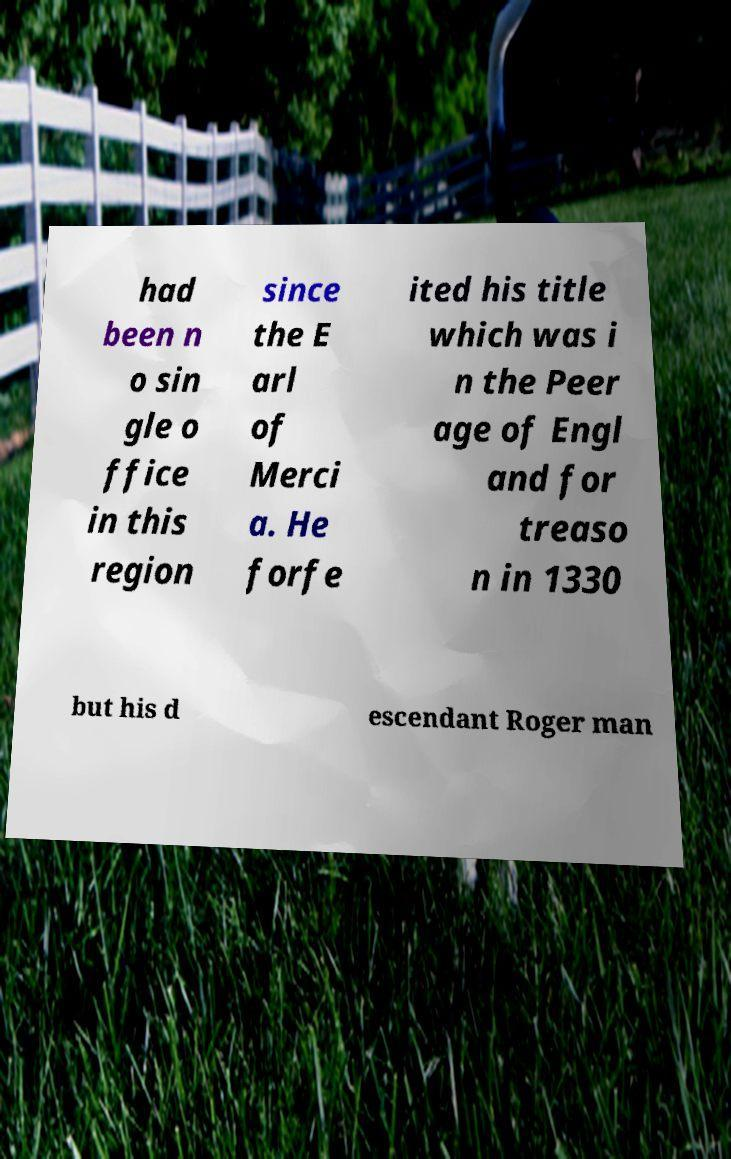Can you accurately transcribe the text from the provided image for me? had been n o sin gle o ffice in this region since the E arl of Merci a. He forfe ited his title which was i n the Peer age of Engl and for treaso n in 1330 but his d escendant Roger man 